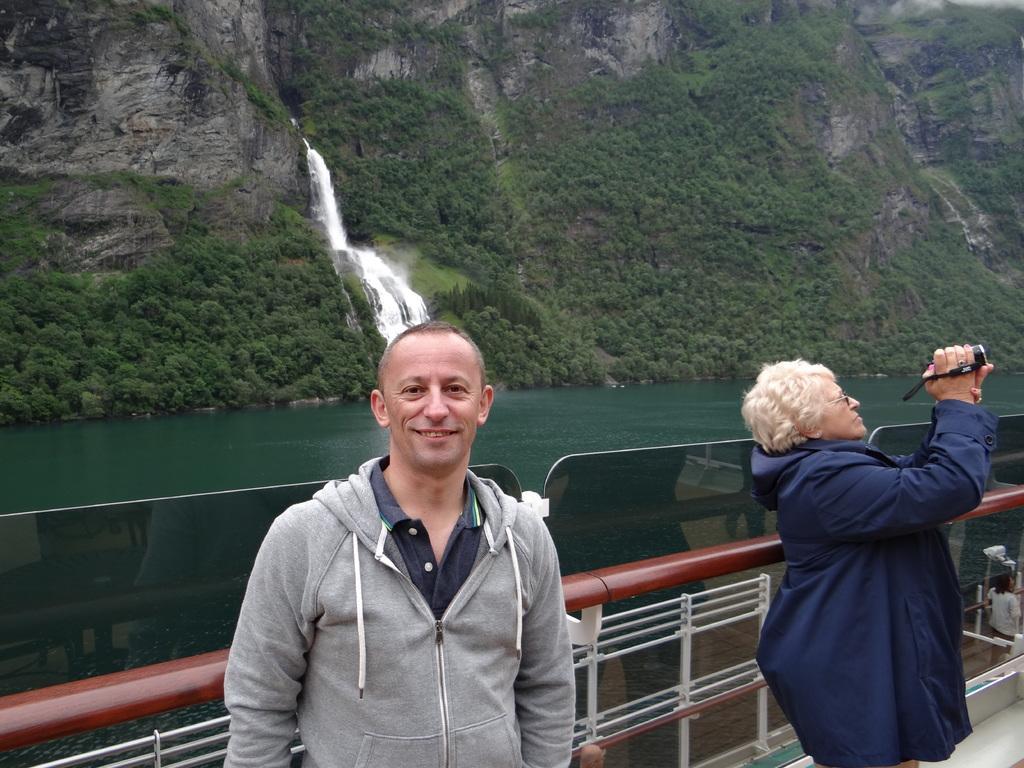In one or two sentences, can you explain what this image depicts? In this image there is a person standing and smiling,another person standing and holding a camera, and in the background there is waterfall, water, trees, iron grills. 